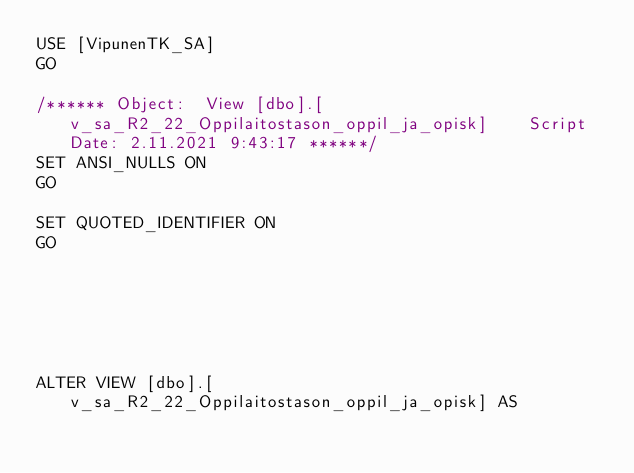<code> <loc_0><loc_0><loc_500><loc_500><_SQL_>USE [VipunenTK_SA]
GO

/****** Object:  View [dbo].[v_sa_R2_22_Oppilaitostason_oppil_ja_opisk]    Script Date: 2.11.2021 9:43:17 ******/
SET ANSI_NULLS ON
GO

SET QUOTED_IDENTIFIER ON
GO






ALTER VIEW [dbo].[v_sa_R2_22_Oppilaitostason_oppil_ja_opisk] AS</code> 